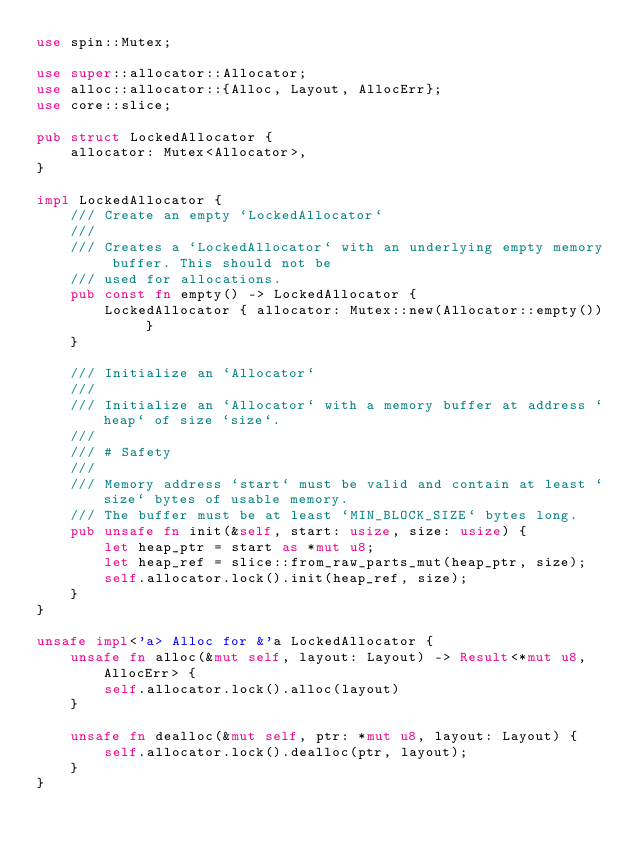Convert code to text. <code><loc_0><loc_0><loc_500><loc_500><_Rust_>use spin::Mutex;

use super::allocator::Allocator;
use alloc::allocator::{Alloc, Layout, AllocErr};
use core::slice;

pub struct LockedAllocator {
    allocator: Mutex<Allocator>,
}

impl LockedAllocator {
    /// Create an empty `LockedAllocator`
    ///
    /// Creates a `LockedAllocator` with an underlying empty memory buffer. This should not be
    /// used for allocations.
    pub const fn empty() -> LockedAllocator {
        LockedAllocator { allocator: Mutex::new(Allocator::empty()) }
    }

    /// Initialize an `Allocator`
    ///
    /// Initialize an `Allocator` with a memory buffer at address `heap` of size `size`.
    ///
    /// # Safety
    ///
    /// Memory address `start` must be valid and contain at least `size` bytes of usable memory.
    /// The buffer must be at least `MIN_BLOCK_SIZE` bytes long.
    pub unsafe fn init(&self, start: usize, size: usize) {
        let heap_ptr = start as *mut u8;
        let heap_ref = slice::from_raw_parts_mut(heap_ptr, size);
        self.allocator.lock().init(heap_ref, size);
    }
}

unsafe impl<'a> Alloc for &'a LockedAllocator {
    unsafe fn alloc(&mut self, layout: Layout) -> Result<*mut u8, AllocErr> {
        self.allocator.lock().alloc(layout)
    }

    unsafe fn dealloc(&mut self, ptr: *mut u8, layout: Layout) {
        self.allocator.lock().dealloc(ptr, layout);
    }
}
</code> 